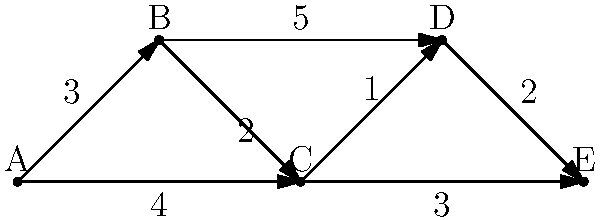As the international marketing director, you're tasked with optimizing travel routes for summit speakers. The graph represents cities connected by flights, with travel times (in hours) indicated on each edge. What is the shortest total travel time from city A to city E? To find the shortest path from A to E, we'll use Dijkstra's algorithm:

1. Initialize:
   - Distance to A: 0
   - Distance to all other nodes: ∞

2. Start at A:
   - Update B: min(∞, 0 + 3) = 3
   - Update C: min(∞, 0 + 4) = 4

3. Move to B (closest unvisited node):
   - Update C: min(4, 3 + 2) = 4 (no change)
   - Update D: min(∞, 3 + 5) = 8

4. Move to C:
   - Update D: min(8, 4 + 1) = 5
   - Update E: min(∞, 4 + 3) = 7

5. Move to D:
   - Update E: min(7, 5 + 2) = 7 (no change)

6. Move to E (destination reached)

The shortest path is A → C → D → E with a total travel time of 7 hours.
Answer: 7 hours 